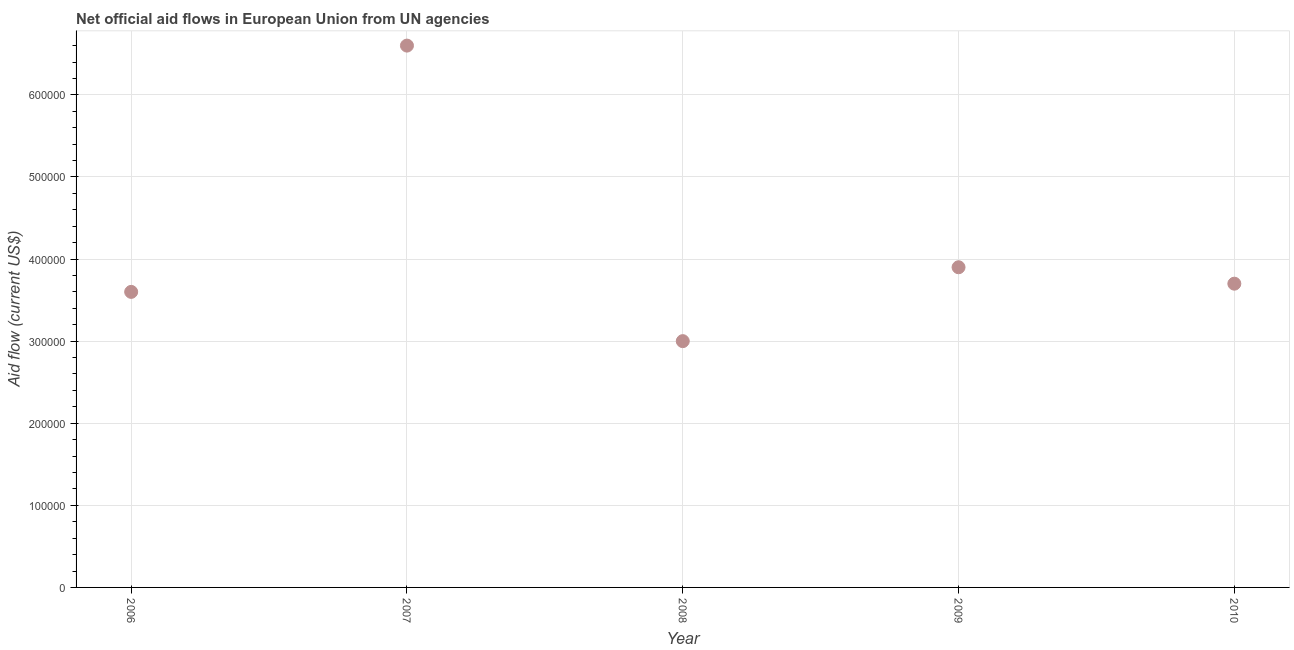What is the net official flows from un agencies in 2009?
Provide a succinct answer. 3.90e+05. Across all years, what is the maximum net official flows from un agencies?
Your answer should be compact. 6.60e+05. Across all years, what is the minimum net official flows from un agencies?
Your response must be concise. 3.00e+05. What is the sum of the net official flows from un agencies?
Your answer should be very brief. 2.08e+06. What is the difference between the net official flows from un agencies in 2007 and 2008?
Provide a short and direct response. 3.60e+05. What is the average net official flows from un agencies per year?
Keep it short and to the point. 4.16e+05. Do a majority of the years between 2009 and 2006 (inclusive) have net official flows from un agencies greater than 500000 US$?
Your answer should be very brief. Yes. What is the ratio of the net official flows from un agencies in 2007 to that in 2010?
Offer a terse response. 1.78. Is the net official flows from un agencies in 2007 less than that in 2010?
Provide a succinct answer. No. Is the difference between the net official flows from un agencies in 2008 and 2009 greater than the difference between any two years?
Your answer should be compact. No. Is the sum of the net official flows from un agencies in 2009 and 2010 greater than the maximum net official flows from un agencies across all years?
Offer a terse response. Yes. What is the difference between the highest and the lowest net official flows from un agencies?
Your answer should be very brief. 3.60e+05. Does the net official flows from un agencies monotonically increase over the years?
Make the answer very short. No. Does the graph contain grids?
Your answer should be compact. Yes. What is the title of the graph?
Make the answer very short. Net official aid flows in European Union from UN agencies. What is the Aid flow (current US$) in 2008?
Offer a terse response. 3.00e+05. What is the Aid flow (current US$) in 2009?
Provide a succinct answer. 3.90e+05. What is the difference between the Aid flow (current US$) in 2006 and 2009?
Ensure brevity in your answer.  -3.00e+04. What is the difference between the Aid flow (current US$) in 2007 and 2009?
Make the answer very short. 2.70e+05. What is the difference between the Aid flow (current US$) in 2007 and 2010?
Your answer should be very brief. 2.90e+05. What is the difference between the Aid flow (current US$) in 2008 and 2009?
Provide a short and direct response. -9.00e+04. What is the difference between the Aid flow (current US$) in 2008 and 2010?
Keep it short and to the point. -7.00e+04. What is the ratio of the Aid flow (current US$) in 2006 to that in 2007?
Keep it short and to the point. 0.55. What is the ratio of the Aid flow (current US$) in 2006 to that in 2009?
Your response must be concise. 0.92. What is the ratio of the Aid flow (current US$) in 2007 to that in 2009?
Make the answer very short. 1.69. What is the ratio of the Aid flow (current US$) in 2007 to that in 2010?
Give a very brief answer. 1.78. What is the ratio of the Aid flow (current US$) in 2008 to that in 2009?
Offer a very short reply. 0.77. What is the ratio of the Aid flow (current US$) in 2008 to that in 2010?
Offer a very short reply. 0.81. What is the ratio of the Aid flow (current US$) in 2009 to that in 2010?
Keep it short and to the point. 1.05. 